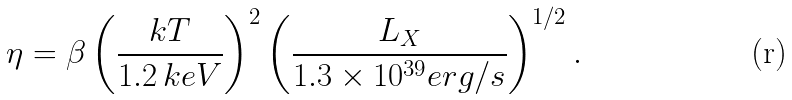Convert formula to latex. <formula><loc_0><loc_0><loc_500><loc_500>\eta = \beta \left ( \frac { k T } { 1 . 2 \, k e V } \right ) ^ { 2 } \left ( \frac { L _ { X } } { 1 . 3 \times 1 0 ^ { 3 9 } e r g / s } \right ) ^ { 1 / 2 } .</formula> 